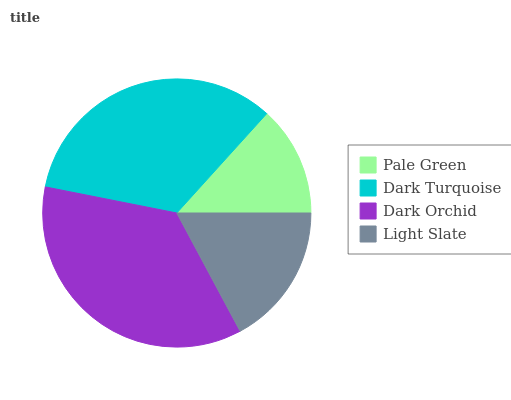Is Pale Green the minimum?
Answer yes or no. Yes. Is Dark Orchid the maximum?
Answer yes or no. Yes. Is Dark Turquoise the minimum?
Answer yes or no. No. Is Dark Turquoise the maximum?
Answer yes or no. No. Is Dark Turquoise greater than Pale Green?
Answer yes or no. Yes. Is Pale Green less than Dark Turquoise?
Answer yes or no. Yes. Is Pale Green greater than Dark Turquoise?
Answer yes or no. No. Is Dark Turquoise less than Pale Green?
Answer yes or no. No. Is Dark Turquoise the high median?
Answer yes or no. Yes. Is Light Slate the low median?
Answer yes or no. Yes. Is Dark Orchid the high median?
Answer yes or no. No. Is Pale Green the low median?
Answer yes or no. No. 